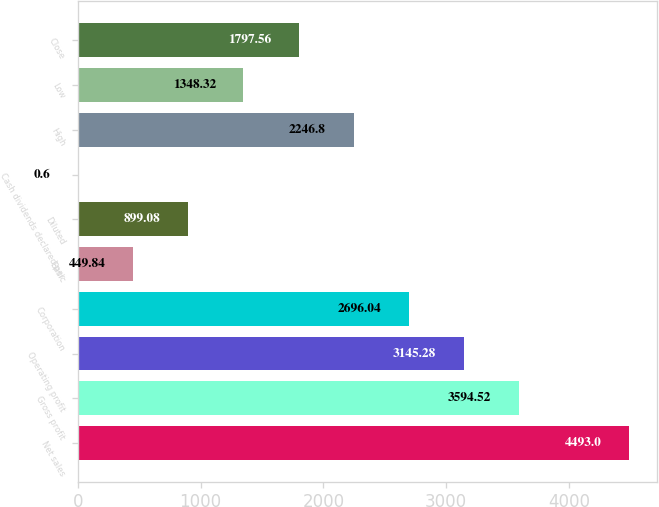Convert chart. <chart><loc_0><loc_0><loc_500><loc_500><bar_chart><fcel>Net sales<fcel>Gross profit<fcel>Operating profit<fcel>Corporation<fcel>Basic<fcel>Diluted<fcel>Cash dividends declared per<fcel>High<fcel>Low<fcel>Close<nl><fcel>4493<fcel>3594.52<fcel>3145.28<fcel>2696.04<fcel>449.84<fcel>899.08<fcel>0.6<fcel>2246.8<fcel>1348.32<fcel>1797.56<nl></chart> 